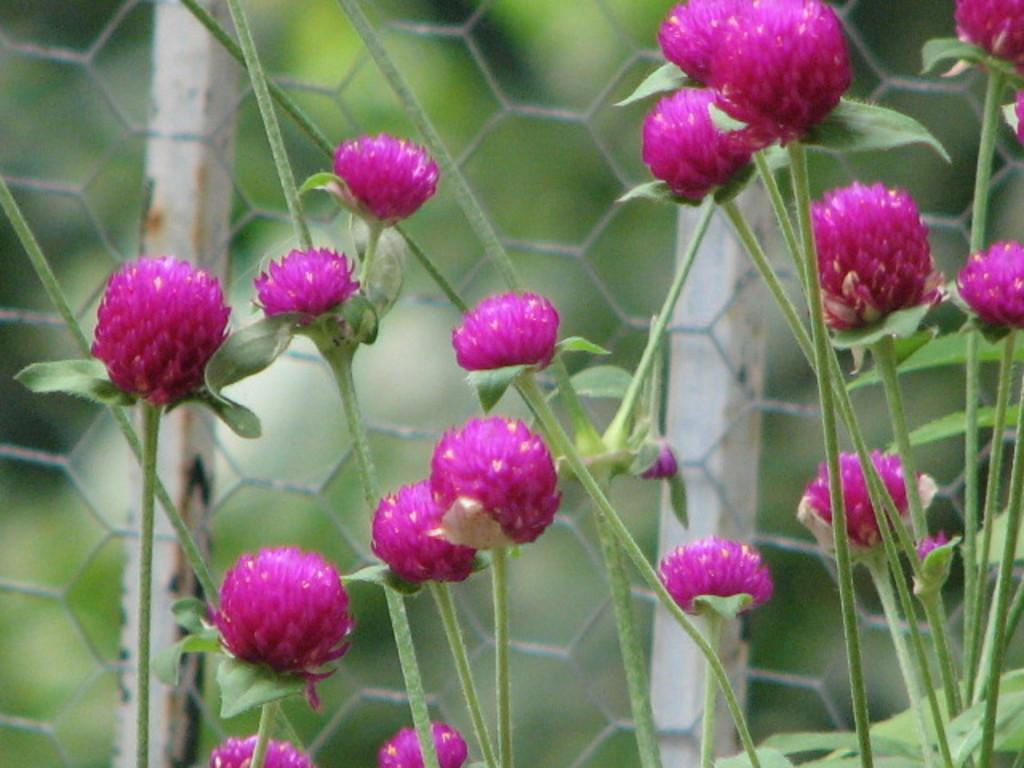What type of flowers are on the plant in the image? There are red flowers on the plant in the image. What can be seen in the foreground of the image? Fencing is visible in the foreground of the image. How would you describe the background of the image? The background of the image appears blurry. What type of insurance policy is being discussed in the image? There is no discussion of insurance policies in the image; it features a plant with red flowers and fencing in the foreground. 